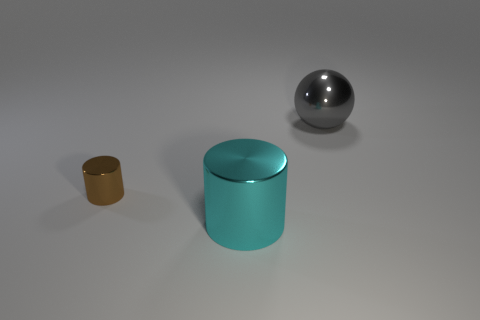Are there any other things that have the same size as the brown cylinder?
Offer a very short reply. No. There is a brown object; is its size the same as the metallic cylinder that is on the right side of the brown shiny cylinder?
Your answer should be very brief. No. Are there more small red cylinders than big metallic cylinders?
Make the answer very short. No. Is the material of the thing behind the tiny brown object the same as the thing that is on the left side of the cyan object?
Ensure brevity in your answer.  Yes. What is the material of the gray thing?
Ensure brevity in your answer.  Metal. Is the number of small brown cylinders right of the small brown cylinder greater than the number of big metallic balls?
Give a very brief answer. No. How many large gray spheres are behind the big metallic object to the left of the large object behind the cyan cylinder?
Make the answer very short. 1. What is the object that is behind the cyan object and left of the metallic sphere made of?
Your answer should be compact. Metal. The small object is what color?
Offer a terse response. Brown. Are there more big metallic cylinders that are on the left side of the large cylinder than big metallic cylinders behind the tiny object?
Give a very brief answer. No. 